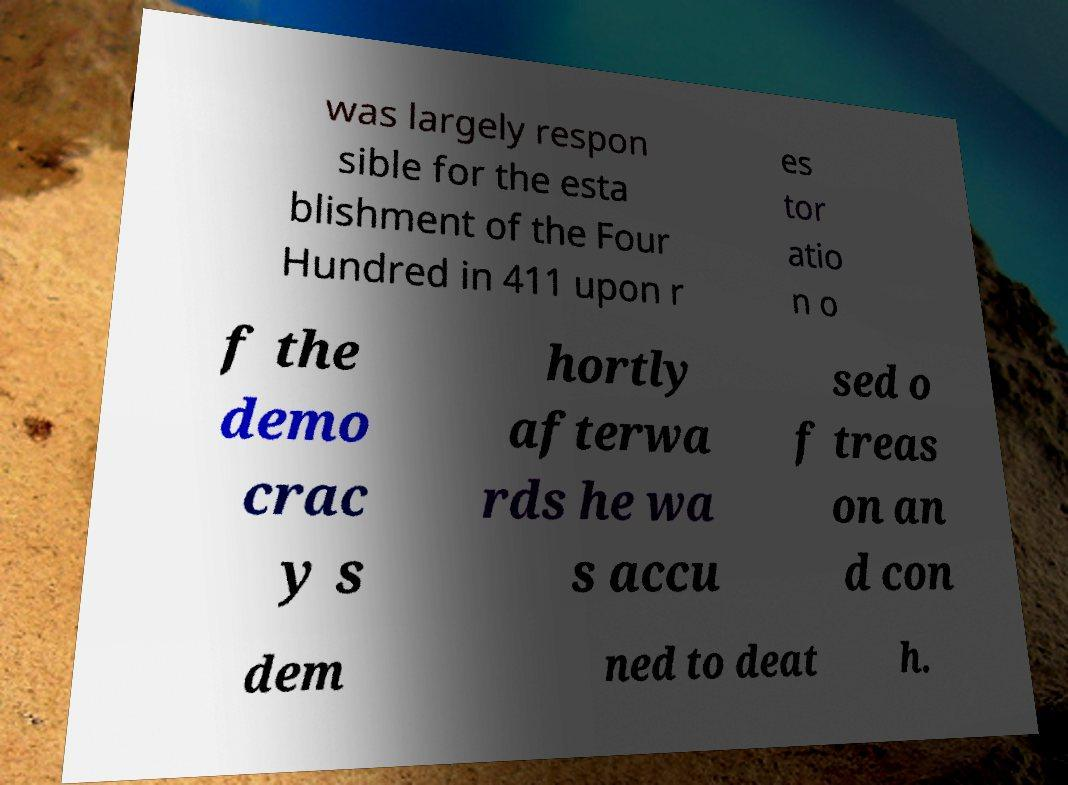There's text embedded in this image that I need extracted. Can you transcribe it verbatim? was largely respon sible for the esta blishment of the Four Hundred in 411 upon r es tor atio n o f the demo crac y s hortly afterwa rds he wa s accu sed o f treas on an d con dem ned to deat h. 